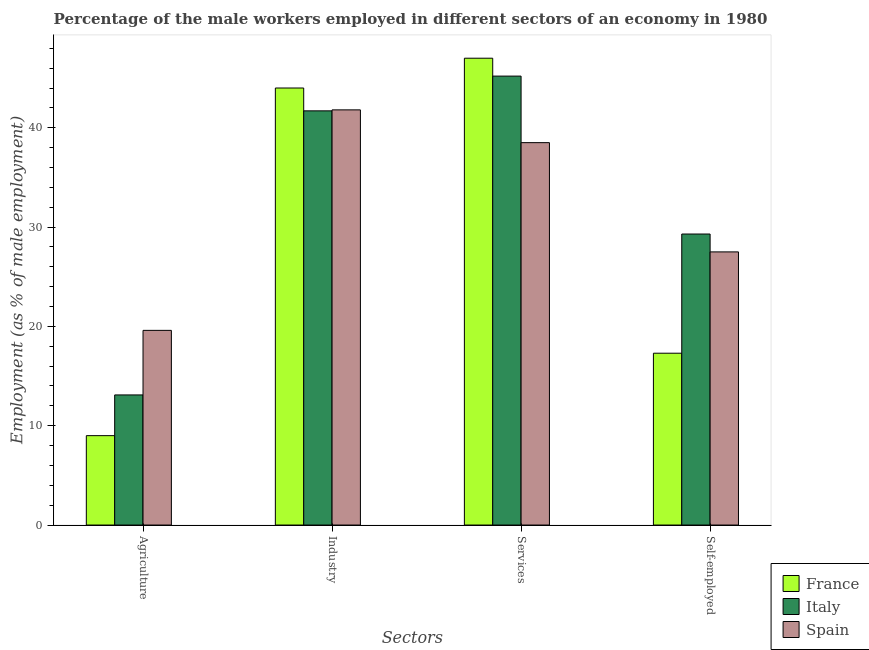How many different coloured bars are there?
Provide a short and direct response. 3. Are the number of bars per tick equal to the number of legend labels?
Make the answer very short. Yes. Are the number of bars on each tick of the X-axis equal?
Give a very brief answer. Yes. How many bars are there on the 4th tick from the left?
Ensure brevity in your answer.  3. How many bars are there on the 1st tick from the right?
Provide a short and direct response. 3. What is the label of the 4th group of bars from the left?
Give a very brief answer. Self-employed. What is the percentage of self employed male workers in France?
Offer a very short reply. 17.3. Across all countries, what is the maximum percentage of male workers in agriculture?
Offer a very short reply. 19.6. Across all countries, what is the minimum percentage of male workers in industry?
Give a very brief answer. 41.7. In which country was the percentage of male workers in services maximum?
Provide a short and direct response. France. In which country was the percentage of male workers in industry minimum?
Make the answer very short. Italy. What is the total percentage of male workers in agriculture in the graph?
Your response must be concise. 41.7. What is the difference between the percentage of male workers in industry in Spain and that in France?
Ensure brevity in your answer.  -2.2. What is the difference between the percentage of self employed male workers in Italy and the percentage of male workers in industry in France?
Provide a short and direct response. -14.7. What is the average percentage of male workers in services per country?
Make the answer very short. 43.57. What is the difference between the percentage of self employed male workers and percentage of male workers in industry in Spain?
Ensure brevity in your answer.  -14.3. In how many countries, is the percentage of male workers in industry greater than 22 %?
Offer a terse response. 3. What is the ratio of the percentage of male workers in industry in Italy to that in France?
Your answer should be very brief. 0.95. What is the difference between the highest and the second highest percentage of male workers in services?
Offer a very short reply. 1.8. In how many countries, is the percentage of male workers in industry greater than the average percentage of male workers in industry taken over all countries?
Provide a succinct answer. 1. Is the sum of the percentage of male workers in industry in France and Italy greater than the maximum percentage of male workers in agriculture across all countries?
Offer a terse response. Yes. What does the 3rd bar from the left in Industry represents?
Make the answer very short. Spain. Are all the bars in the graph horizontal?
Provide a succinct answer. No. Does the graph contain any zero values?
Provide a short and direct response. No. Where does the legend appear in the graph?
Provide a short and direct response. Bottom right. How many legend labels are there?
Make the answer very short. 3. What is the title of the graph?
Your answer should be compact. Percentage of the male workers employed in different sectors of an economy in 1980. Does "Hong Kong" appear as one of the legend labels in the graph?
Offer a terse response. No. What is the label or title of the X-axis?
Keep it short and to the point. Sectors. What is the label or title of the Y-axis?
Make the answer very short. Employment (as % of male employment). What is the Employment (as % of male employment) of Italy in Agriculture?
Offer a very short reply. 13.1. What is the Employment (as % of male employment) of Spain in Agriculture?
Your answer should be very brief. 19.6. What is the Employment (as % of male employment) of Italy in Industry?
Your response must be concise. 41.7. What is the Employment (as % of male employment) of Spain in Industry?
Your response must be concise. 41.8. What is the Employment (as % of male employment) in Italy in Services?
Your response must be concise. 45.2. What is the Employment (as % of male employment) in Spain in Services?
Offer a very short reply. 38.5. What is the Employment (as % of male employment) of France in Self-employed?
Keep it short and to the point. 17.3. What is the Employment (as % of male employment) in Italy in Self-employed?
Your answer should be very brief. 29.3. What is the Employment (as % of male employment) in Spain in Self-employed?
Offer a terse response. 27.5. Across all Sectors, what is the maximum Employment (as % of male employment) in France?
Offer a very short reply. 47. Across all Sectors, what is the maximum Employment (as % of male employment) of Italy?
Keep it short and to the point. 45.2. Across all Sectors, what is the maximum Employment (as % of male employment) of Spain?
Your response must be concise. 41.8. Across all Sectors, what is the minimum Employment (as % of male employment) in France?
Give a very brief answer. 9. Across all Sectors, what is the minimum Employment (as % of male employment) of Italy?
Give a very brief answer. 13.1. Across all Sectors, what is the minimum Employment (as % of male employment) of Spain?
Keep it short and to the point. 19.6. What is the total Employment (as % of male employment) of France in the graph?
Give a very brief answer. 117.3. What is the total Employment (as % of male employment) in Italy in the graph?
Your answer should be compact. 129.3. What is the total Employment (as % of male employment) in Spain in the graph?
Offer a terse response. 127.4. What is the difference between the Employment (as % of male employment) of France in Agriculture and that in Industry?
Provide a short and direct response. -35. What is the difference between the Employment (as % of male employment) of Italy in Agriculture and that in Industry?
Provide a short and direct response. -28.6. What is the difference between the Employment (as % of male employment) of Spain in Agriculture and that in Industry?
Your response must be concise. -22.2. What is the difference between the Employment (as % of male employment) in France in Agriculture and that in Services?
Offer a very short reply. -38. What is the difference between the Employment (as % of male employment) in Italy in Agriculture and that in Services?
Your answer should be very brief. -32.1. What is the difference between the Employment (as % of male employment) in Spain in Agriculture and that in Services?
Offer a very short reply. -18.9. What is the difference between the Employment (as % of male employment) of Italy in Agriculture and that in Self-employed?
Offer a terse response. -16.2. What is the difference between the Employment (as % of male employment) of Spain in Agriculture and that in Self-employed?
Make the answer very short. -7.9. What is the difference between the Employment (as % of male employment) in France in Industry and that in Services?
Make the answer very short. -3. What is the difference between the Employment (as % of male employment) of Spain in Industry and that in Services?
Your response must be concise. 3.3. What is the difference between the Employment (as % of male employment) of France in Industry and that in Self-employed?
Provide a short and direct response. 26.7. What is the difference between the Employment (as % of male employment) of Spain in Industry and that in Self-employed?
Give a very brief answer. 14.3. What is the difference between the Employment (as % of male employment) in France in Services and that in Self-employed?
Provide a short and direct response. 29.7. What is the difference between the Employment (as % of male employment) of France in Agriculture and the Employment (as % of male employment) of Italy in Industry?
Make the answer very short. -32.7. What is the difference between the Employment (as % of male employment) in France in Agriculture and the Employment (as % of male employment) in Spain in Industry?
Your answer should be compact. -32.8. What is the difference between the Employment (as % of male employment) of Italy in Agriculture and the Employment (as % of male employment) of Spain in Industry?
Your response must be concise. -28.7. What is the difference between the Employment (as % of male employment) of France in Agriculture and the Employment (as % of male employment) of Italy in Services?
Your response must be concise. -36.2. What is the difference between the Employment (as % of male employment) of France in Agriculture and the Employment (as % of male employment) of Spain in Services?
Provide a short and direct response. -29.5. What is the difference between the Employment (as % of male employment) in Italy in Agriculture and the Employment (as % of male employment) in Spain in Services?
Ensure brevity in your answer.  -25.4. What is the difference between the Employment (as % of male employment) in France in Agriculture and the Employment (as % of male employment) in Italy in Self-employed?
Offer a terse response. -20.3. What is the difference between the Employment (as % of male employment) of France in Agriculture and the Employment (as % of male employment) of Spain in Self-employed?
Your answer should be very brief. -18.5. What is the difference between the Employment (as % of male employment) in Italy in Agriculture and the Employment (as % of male employment) in Spain in Self-employed?
Your answer should be very brief. -14.4. What is the difference between the Employment (as % of male employment) of France in Industry and the Employment (as % of male employment) of Italy in Services?
Offer a very short reply. -1.2. What is the difference between the Employment (as % of male employment) in France in Industry and the Employment (as % of male employment) in Spain in Services?
Your response must be concise. 5.5. What is the difference between the Employment (as % of male employment) of Italy in Industry and the Employment (as % of male employment) of Spain in Services?
Make the answer very short. 3.2. What is the difference between the Employment (as % of male employment) of France in Industry and the Employment (as % of male employment) of Spain in Self-employed?
Give a very brief answer. 16.5. What is the difference between the Employment (as % of male employment) in Italy in Industry and the Employment (as % of male employment) in Spain in Self-employed?
Ensure brevity in your answer.  14.2. What is the difference between the Employment (as % of male employment) of France in Services and the Employment (as % of male employment) of Italy in Self-employed?
Ensure brevity in your answer.  17.7. What is the difference between the Employment (as % of male employment) in France in Services and the Employment (as % of male employment) in Spain in Self-employed?
Ensure brevity in your answer.  19.5. What is the average Employment (as % of male employment) of France per Sectors?
Your answer should be very brief. 29.32. What is the average Employment (as % of male employment) of Italy per Sectors?
Give a very brief answer. 32.33. What is the average Employment (as % of male employment) in Spain per Sectors?
Offer a terse response. 31.85. What is the difference between the Employment (as % of male employment) of France and Employment (as % of male employment) of Italy in Agriculture?
Your answer should be compact. -4.1. What is the difference between the Employment (as % of male employment) of France and Employment (as % of male employment) of Spain in Agriculture?
Ensure brevity in your answer.  -10.6. What is the difference between the Employment (as % of male employment) in Italy and Employment (as % of male employment) in Spain in Agriculture?
Give a very brief answer. -6.5. What is the difference between the Employment (as % of male employment) of France and Employment (as % of male employment) of Italy in Industry?
Give a very brief answer. 2.3. What is the difference between the Employment (as % of male employment) of France and Employment (as % of male employment) of Spain in Self-employed?
Offer a terse response. -10.2. What is the difference between the Employment (as % of male employment) of Italy and Employment (as % of male employment) of Spain in Self-employed?
Provide a succinct answer. 1.8. What is the ratio of the Employment (as % of male employment) in France in Agriculture to that in Industry?
Make the answer very short. 0.2. What is the ratio of the Employment (as % of male employment) of Italy in Agriculture to that in Industry?
Keep it short and to the point. 0.31. What is the ratio of the Employment (as % of male employment) of Spain in Agriculture to that in Industry?
Offer a terse response. 0.47. What is the ratio of the Employment (as % of male employment) of France in Agriculture to that in Services?
Make the answer very short. 0.19. What is the ratio of the Employment (as % of male employment) of Italy in Agriculture to that in Services?
Your answer should be compact. 0.29. What is the ratio of the Employment (as % of male employment) of Spain in Agriculture to that in Services?
Ensure brevity in your answer.  0.51. What is the ratio of the Employment (as % of male employment) of France in Agriculture to that in Self-employed?
Give a very brief answer. 0.52. What is the ratio of the Employment (as % of male employment) in Italy in Agriculture to that in Self-employed?
Ensure brevity in your answer.  0.45. What is the ratio of the Employment (as % of male employment) in Spain in Agriculture to that in Self-employed?
Your answer should be very brief. 0.71. What is the ratio of the Employment (as % of male employment) in France in Industry to that in Services?
Offer a terse response. 0.94. What is the ratio of the Employment (as % of male employment) of Italy in Industry to that in Services?
Your answer should be very brief. 0.92. What is the ratio of the Employment (as % of male employment) in Spain in Industry to that in Services?
Make the answer very short. 1.09. What is the ratio of the Employment (as % of male employment) in France in Industry to that in Self-employed?
Make the answer very short. 2.54. What is the ratio of the Employment (as % of male employment) of Italy in Industry to that in Self-employed?
Your answer should be very brief. 1.42. What is the ratio of the Employment (as % of male employment) in Spain in Industry to that in Self-employed?
Ensure brevity in your answer.  1.52. What is the ratio of the Employment (as % of male employment) of France in Services to that in Self-employed?
Ensure brevity in your answer.  2.72. What is the ratio of the Employment (as % of male employment) in Italy in Services to that in Self-employed?
Your answer should be compact. 1.54. What is the difference between the highest and the second highest Employment (as % of male employment) of France?
Make the answer very short. 3. What is the difference between the highest and the second highest Employment (as % of male employment) in Italy?
Ensure brevity in your answer.  3.5. What is the difference between the highest and the lowest Employment (as % of male employment) in Italy?
Your answer should be very brief. 32.1. What is the difference between the highest and the lowest Employment (as % of male employment) in Spain?
Your response must be concise. 22.2. 